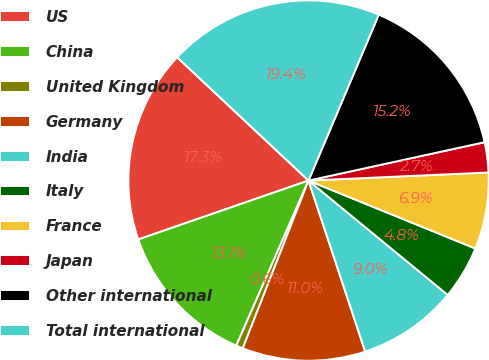Convert chart. <chart><loc_0><loc_0><loc_500><loc_500><pie_chart><fcel>US<fcel>China<fcel>United Kingdom<fcel>Germany<fcel>India<fcel>Italy<fcel>France<fcel>Japan<fcel>Other international<fcel>Total international<nl><fcel>17.3%<fcel>13.13%<fcel>0.62%<fcel>11.04%<fcel>8.96%<fcel>4.79%<fcel>6.87%<fcel>2.7%<fcel>15.21%<fcel>19.38%<nl></chart> 